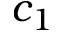<formula> <loc_0><loc_0><loc_500><loc_500>c _ { 1 }</formula> 